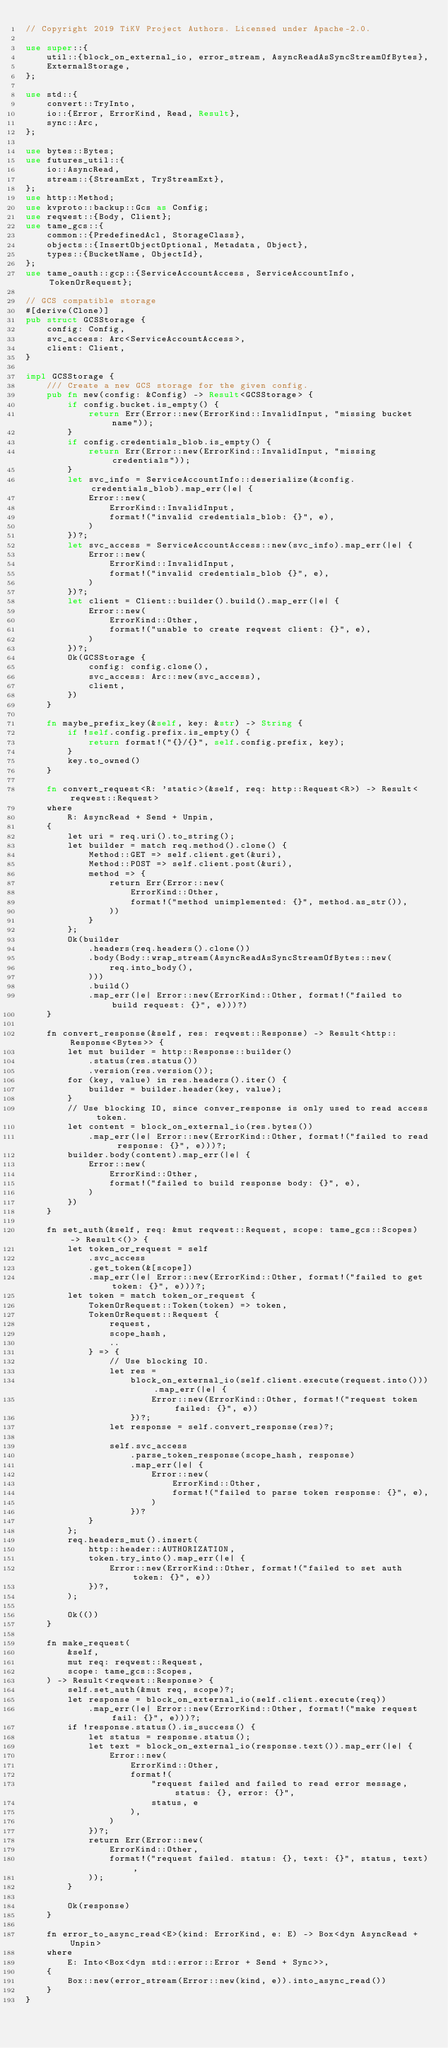Convert code to text. <code><loc_0><loc_0><loc_500><loc_500><_Rust_>// Copyright 2019 TiKV Project Authors. Licensed under Apache-2.0.

use super::{
    util::{block_on_external_io, error_stream, AsyncReadAsSyncStreamOfBytes},
    ExternalStorage,
};

use std::{
    convert::TryInto,
    io::{Error, ErrorKind, Read, Result},
    sync::Arc,
};

use bytes::Bytes;
use futures_util::{
    io::AsyncRead,
    stream::{StreamExt, TryStreamExt},
};
use http::Method;
use kvproto::backup::Gcs as Config;
use reqwest::{Body, Client};
use tame_gcs::{
    common::{PredefinedAcl, StorageClass},
    objects::{InsertObjectOptional, Metadata, Object},
    types::{BucketName, ObjectId},
};
use tame_oauth::gcp::{ServiceAccountAccess, ServiceAccountInfo, TokenOrRequest};

// GCS compatible storage
#[derive(Clone)]
pub struct GCSStorage {
    config: Config,
    svc_access: Arc<ServiceAccountAccess>,
    client: Client,
}

impl GCSStorage {
    /// Create a new GCS storage for the given config.
    pub fn new(config: &Config) -> Result<GCSStorage> {
        if config.bucket.is_empty() {
            return Err(Error::new(ErrorKind::InvalidInput, "missing bucket name"));
        }
        if config.credentials_blob.is_empty() {
            return Err(Error::new(ErrorKind::InvalidInput, "missing credentials"));
        }
        let svc_info = ServiceAccountInfo::deserialize(&config.credentials_blob).map_err(|e| {
            Error::new(
                ErrorKind::InvalidInput,
                format!("invalid credentials_blob: {}", e),
            )
        })?;
        let svc_access = ServiceAccountAccess::new(svc_info).map_err(|e| {
            Error::new(
                ErrorKind::InvalidInput,
                format!("invalid credentials_blob {}", e),
            )
        })?;
        let client = Client::builder().build().map_err(|e| {
            Error::new(
                ErrorKind::Other,
                format!("unable to create reqwest client: {}", e),
            )
        })?;
        Ok(GCSStorage {
            config: config.clone(),
            svc_access: Arc::new(svc_access),
            client,
        })
    }

    fn maybe_prefix_key(&self, key: &str) -> String {
        if !self.config.prefix.is_empty() {
            return format!("{}/{}", self.config.prefix, key);
        }
        key.to_owned()
    }

    fn convert_request<R: 'static>(&self, req: http::Request<R>) -> Result<reqwest::Request>
    where
        R: AsyncRead + Send + Unpin,
    {
        let uri = req.uri().to_string();
        let builder = match req.method().clone() {
            Method::GET => self.client.get(&uri),
            Method::POST => self.client.post(&uri),
            method => {
                return Err(Error::new(
                    ErrorKind::Other,
                    format!("method unimplemented: {}", method.as_str()),
                ))
            }
        };
        Ok(builder
            .headers(req.headers().clone())
            .body(Body::wrap_stream(AsyncReadAsSyncStreamOfBytes::new(
                req.into_body(),
            )))
            .build()
            .map_err(|e| Error::new(ErrorKind::Other, format!("failed to build request: {}", e)))?)
    }

    fn convert_response(&self, res: reqwest::Response) -> Result<http::Response<Bytes>> {
        let mut builder = http::Response::builder()
            .status(res.status())
            .version(res.version());
        for (key, value) in res.headers().iter() {
            builder = builder.header(key, value);
        }
        // Use blocking IO, since conver_response is only used to read access token.
        let content = block_on_external_io(res.bytes())
            .map_err(|e| Error::new(ErrorKind::Other, format!("failed to read response: {}", e)))?;
        builder.body(content).map_err(|e| {
            Error::new(
                ErrorKind::Other,
                format!("failed to build response body: {}", e),
            )
        })
    }

    fn set_auth(&self, req: &mut reqwest::Request, scope: tame_gcs::Scopes) -> Result<()> {
        let token_or_request = self
            .svc_access
            .get_token(&[scope])
            .map_err(|e| Error::new(ErrorKind::Other, format!("failed to get token: {}", e)))?;
        let token = match token_or_request {
            TokenOrRequest::Token(token) => token,
            TokenOrRequest::Request {
                request,
                scope_hash,
                ..
            } => {
                // Use blocking IO.
                let res =
                    block_on_external_io(self.client.execute(request.into())).map_err(|e| {
                        Error::new(ErrorKind::Other, format!("request token failed: {}", e))
                    })?;
                let response = self.convert_response(res)?;

                self.svc_access
                    .parse_token_response(scope_hash, response)
                    .map_err(|e| {
                        Error::new(
                            ErrorKind::Other,
                            format!("failed to parse token response: {}", e),
                        )
                    })?
            }
        };
        req.headers_mut().insert(
            http::header::AUTHORIZATION,
            token.try_into().map_err(|e| {
                Error::new(ErrorKind::Other, format!("failed to set auth token: {}", e))
            })?,
        );

        Ok(())
    }

    fn make_request(
        &self,
        mut req: reqwest::Request,
        scope: tame_gcs::Scopes,
    ) -> Result<reqwest::Response> {
        self.set_auth(&mut req, scope)?;
        let response = block_on_external_io(self.client.execute(req))
            .map_err(|e| Error::new(ErrorKind::Other, format!("make request fail: {}", e)))?;
        if !response.status().is_success() {
            let status = response.status();
            let text = block_on_external_io(response.text()).map_err(|e| {
                Error::new(
                    ErrorKind::Other,
                    format!(
                        "request failed and failed to read error message, status: {}, error: {}",
                        status, e
                    ),
                )
            })?;
            return Err(Error::new(
                ErrorKind::Other,
                format!("request failed. status: {}, text: {}", status, text),
            ));
        }

        Ok(response)
    }

    fn error_to_async_read<E>(kind: ErrorKind, e: E) -> Box<dyn AsyncRead + Unpin>
    where
        E: Into<Box<dyn std::error::Error + Send + Sync>>,
    {
        Box::new(error_stream(Error::new(kind, e)).into_async_read())
    }
}
</code> 